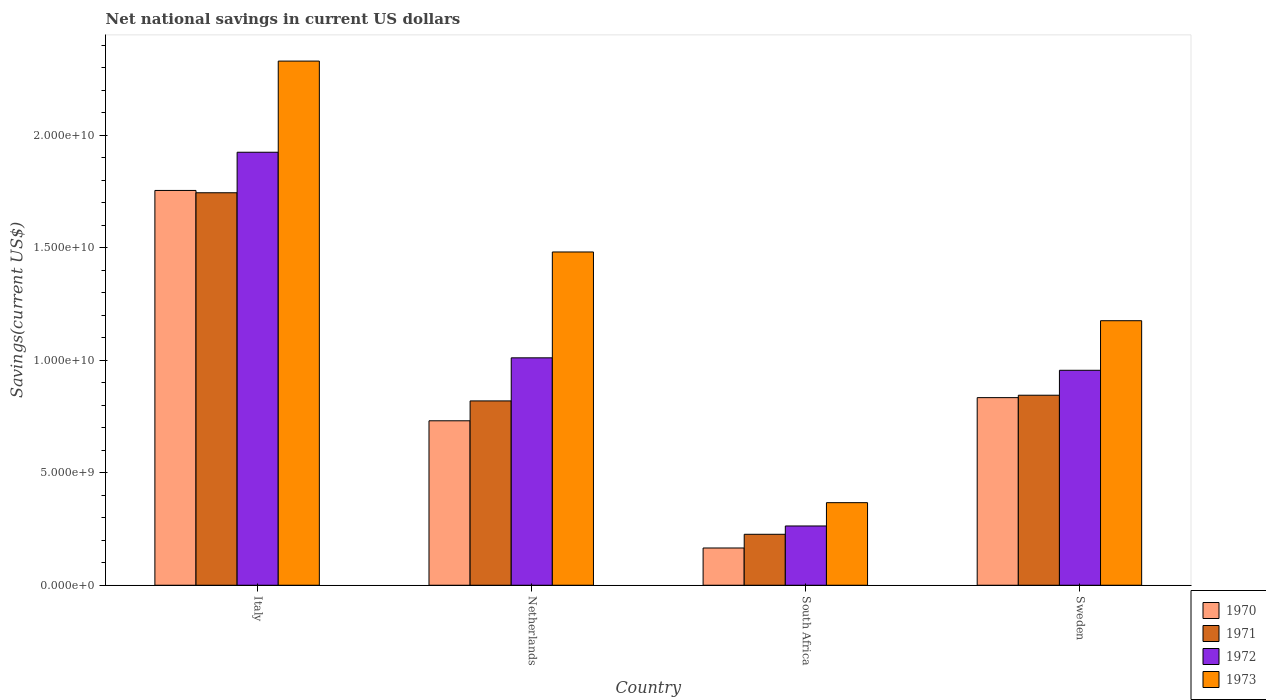How many different coloured bars are there?
Provide a succinct answer. 4. How many groups of bars are there?
Give a very brief answer. 4. How many bars are there on the 2nd tick from the left?
Keep it short and to the point. 4. What is the net national savings in 1972 in Italy?
Offer a terse response. 1.93e+1. Across all countries, what is the maximum net national savings in 1972?
Your answer should be compact. 1.93e+1. Across all countries, what is the minimum net national savings in 1971?
Give a very brief answer. 2.27e+09. In which country was the net national savings in 1972 minimum?
Your answer should be compact. South Africa. What is the total net national savings in 1970 in the graph?
Ensure brevity in your answer.  3.49e+1. What is the difference between the net national savings in 1973 in South Africa and that in Sweden?
Give a very brief answer. -8.09e+09. What is the difference between the net national savings in 1971 in Sweden and the net national savings in 1973 in South Africa?
Offer a very short reply. 4.78e+09. What is the average net national savings in 1971 per country?
Your response must be concise. 9.09e+09. What is the difference between the net national savings of/in 1971 and net national savings of/in 1973 in Italy?
Ensure brevity in your answer.  -5.86e+09. In how many countries, is the net national savings in 1972 greater than 2000000000 US$?
Your answer should be very brief. 4. What is the ratio of the net national savings in 1972 in South Africa to that in Sweden?
Your answer should be compact. 0.28. What is the difference between the highest and the second highest net national savings in 1972?
Provide a short and direct response. -9.14e+09. What is the difference between the highest and the lowest net national savings in 1972?
Your response must be concise. 1.66e+1. Is the sum of the net national savings in 1973 in Netherlands and Sweden greater than the maximum net national savings in 1972 across all countries?
Your response must be concise. Yes. Is it the case that in every country, the sum of the net national savings in 1973 and net national savings in 1970 is greater than the sum of net national savings in 1972 and net national savings in 1971?
Make the answer very short. No. What does the 1st bar from the left in Italy represents?
Make the answer very short. 1970. What does the 4th bar from the right in South Africa represents?
Provide a short and direct response. 1970. How many bars are there?
Keep it short and to the point. 16. Are all the bars in the graph horizontal?
Give a very brief answer. No. How many countries are there in the graph?
Your answer should be very brief. 4. Does the graph contain grids?
Provide a succinct answer. No. How are the legend labels stacked?
Provide a short and direct response. Vertical. What is the title of the graph?
Keep it short and to the point. Net national savings in current US dollars. What is the label or title of the Y-axis?
Offer a very short reply. Savings(current US$). What is the Savings(current US$) of 1970 in Italy?
Your response must be concise. 1.76e+1. What is the Savings(current US$) in 1971 in Italy?
Your answer should be compact. 1.75e+1. What is the Savings(current US$) of 1972 in Italy?
Your answer should be compact. 1.93e+1. What is the Savings(current US$) of 1973 in Italy?
Provide a short and direct response. 2.33e+1. What is the Savings(current US$) of 1970 in Netherlands?
Your answer should be very brief. 7.31e+09. What is the Savings(current US$) in 1971 in Netherlands?
Make the answer very short. 8.20e+09. What is the Savings(current US$) of 1972 in Netherlands?
Offer a terse response. 1.01e+1. What is the Savings(current US$) of 1973 in Netherlands?
Provide a short and direct response. 1.48e+1. What is the Savings(current US$) in 1970 in South Africa?
Provide a short and direct response. 1.66e+09. What is the Savings(current US$) in 1971 in South Africa?
Your answer should be compact. 2.27e+09. What is the Savings(current US$) in 1972 in South Africa?
Ensure brevity in your answer.  2.64e+09. What is the Savings(current US$) of 1973 in South Africa?
Your answer should be very brief. 3.67e+09. What is the Savings(current US$) in 1970 in Sweden?
Offer a terse response. 8.34e+09. What is the Savings(current US$) in 1971 in Sweden?
Your answer should be compact. 8.45e+09. What is the Savings(current US$) of 1972 in Sweden?
Offer a very short reply. 9.56e+09. What is the Savings(current US$) of 1973 in Sweden?
Provide a succinct answer. 1.18e+1. Across all countries, what is the maximum Savings(current US$) in 1970?
Provide a succinct answer. 1.76e+1. Across all countries, what is the maximum Savings(current US$) of 1971?
Offer a terse response. 1.75e+1. Across all countries, what is the maximum Savings(current US$) of 1972?
Offer a terse response. 1.93e+1. Across all countries, what is the maximum Savings(current US$) in 1973?
Keep it short and to the point. 2.33e+1. Across all countries, what is the minimum Savings(current US$) in 1970?
Give a very brief answer. 1.66e+09. Across all countries, what is the minimum Savings(current US$) in 1971?
Give a very brief answer. 2.27e+09. Across all countries, what is the minimum Savings(current US$) of 1972?
Your answer should be very brief. 2.64e+09. Across all countries, what is the minimum Savings(current US$) in 1973?
Make the answer very short. 3.67e+09. What is the total Savings(current US$) in 1970 in the graph?
Your answer should be very brief. 3.49e+1. What is the total Savings(current US$) of 1971 in the graph?
Provide a short and direct response. 3.64e+1. What is the total Savings(current US$) of 1972 in the graph?
Provide a succinct answer. 4.16e+1. What is the total Savings(current US$) of 1973 in the graph?
Your response must be concise. 5.36e+1. What is the difference between the Savings(current US$) of 1970 in Italy and that in Netherlands?
Ensure brevity in your answer.  1.02e+1. What is the difference between the Savings(current US$) of 1971 in Italy and that in Netherlands?
Provide a succinct answer. 9.26e+09. What is the difference between the Savings(current US$) of 1972 in Italy and that in Netherlands?
Ensure brevity in your answer.  9.14e+09. What is the difference between the Savings(current US$) of 1973 in Italy and that in Netherlands?
Your response must be concise. 8.49e+09. What is the difference between the Savings(current US$) of 1970 in Italy and that in South Africa?
Your response must be concise. 1.59e+1. What is the difference between the Savings(current US$) in 1971 in Italy and that in South Africa?
Make the answer very short. 1.52e+1. What is the difference between the Savings(current US$) in 1972 in Italy and that in South Africa?
Provide a succinct answer. 1.66e+1. What is the difference between the Savings(current US$) of 1973 in Italy and that in South Africa?
Provide a succinct answer. 1.96e+1. What is the difference between the Savings(current US$) in 1970 in Italy and that in Sweden?
Make the answer very short. 9.21e+09. What is the difference between the Savings(current US$) in 1971 in Italy and that in Sweden?
Ensure brevity in your answer.  9.00e+09. What is the difference between the Savings(current US$) in 1972 in Italy and that in Sweden?
Offer a very short reply. 9.70e+09. What is the difference between the Savings(current US$) of 1973 in Italy and that in Sweden?
Make the answer very short. 1.15e+1. What is the difference between the Savings(current US$) of 1970 in Netherlands and that in South Africa?
Your answer should be very brief. 5.66e+09. What is the difference between the Savings(current US$) in 1971 in Netherlands and that in South Africa?
Make the answer very short. 5.93e+09. What is the difference between the Savings(current US$) of 1972 in Netherlands and that in South Africa?
Keep it short and to the point. 7.48e+09. What is the difference between the Savings(current US$) of 1973 in Netherlands and that in South Africa?
Ensure brevity in your answer.  1.11e+1. What is the difference between the Savings(current US$) of 1970 in Netherlands and that in Sweden?
Provide a short and direct response. -1.03e+09. What is the difference between the Savings(current US$) in 1971 in Netherlands and that in Sweden?
Give a very brief answer. -2.53e+08. What is the difference between the Savings(current US$) in 1972 in Netherlands and that in Sweden?
Provide a succinct answer. 5.54e+08. What is the difference between the Savings(current US$) in 1973 in Netherlands and that in Sweden?
Ensure brevity in your answer.  3.06e+09. What is the difference between the Savings(current US$) in 1970 in South Africa and that in Sweden?
Your answer should be very brief. -6.69e+09. What is the difference between the Savings(current US$) of 1971 in South Africa and that in Sweden?
Provide a succinct answer. -6.18e+09. What is the difference between the Savings(current US$) of 1972 in South Africa and that in Sweden?
Provide a short and direct response. -6.92e+09. What is the difference between the Savings(current US$) of 1973 in South Africa and that in Sweden?
Provide a succinct answer. -8.09e+09. What is the difference between the Savings(current US$) of 1970 in Italy and the Savings(current US$) of 1971 in Netherlands?
Provide a succinct answer. 9.36e+09. What is the difference between the Savings(current US$) in 1970 in Italy and the Savings(current US$) in 1972 in Netherlands?
Your response must be concise. 7.44e+09. What is the difference between the Savings(current US$) of 1970 in Italy and the Savings(current US$) of 1973 in Netherlands?
Give a very brief answer. 2.74e+09. What is the difference between the Savings(current US$) of 1971 in Italy and the Savings(current US$) of 1972 in Netherlands?
Ensure brevity in your answer.  7.34e+09. What is the difference between the Savings(current US$) of 1971 in Italy and the Savings(current US$) of 1973 in Netherlands?
Your answer should be very brief. 2.63e+09. What is the difference between the Savings(current US$) in 1972 in Italy and the Savings(current US$) in 1973 in Netherlands?
Ensure brevity in your answer.  4.44e+09. What is the difference between the Savings(current US$) in 1970 in Italy and the Savings(current US$) in 1971 in South Africa?
Ensure brevity in your answer.  1.53e+1. What is the difference between the Savings(current US$) of 1970 in Italy and the Savings(current US$) of 1972 in South Africa?
Provide a succinct answer. 1.49e+1. What is the difference between the Savings(current US$) of 1970 in Italy and the Savings(current US$) of 1973 in South Africa?
Your response must be concise. 1.39e+1. What is the difference between the Savings(current US$) of 1971 in Italy and the Savings(current US$) of 1972 in South Africa?
Make the answer very short. 1.48e+1. What is the difference between the Savings(current US$) of 1971 in Italy and the Savings(current US$) of 1973 in South Africa?
Provide a succinct answer. 1.38e+1. What is the difference between the Savings(current US$) in 1972 in Italy and the Savings(current US$) in 1973 in South Africa?
Keep it short and to the point. 1.56e+1. What is the difference between the Savings(current US$) in 1970 in Italy and the Savings(current US$) in 1971 in Sweden?
Keep it short and to the point. 9.11e+09. What is the difference between the Savings(current US$) of 1970 in Italy and the Savings(current US$) of 1972 in Sweden?
Provide a short and direct response. 8.00e+09. What is the difference between the Savings(current US$) in 1970 in Italy and the Savings(current US$) in 1973 in Sweden?
Your answer should be compact. 5.79e+09. What is the difference between the Savings(current US$) in 1971 in Italy and the Savings(current US$) in 1972 in Sweden?
Your answer should be very brief. 7.89e+09. What is the difference between the Savings(current US$) of 1971 in Italy and the Savings(current US$) of 1973 in Sweden?
Your answer should be very brief. 5.69e+09. What is the difference between the Savings(current US$) of 1972 in Italy and the Savings(current US$) of 1973 in Sweden?
Make the answer very short. 7.49e+09. What is the difference between the Savings(current US$) of 1970 in Netherlands and the Savings(current US$) of 1971 in South Africa?
Keep it short and to the point. 5.05e+09. What is the difference between the Savings(current US$) in 1970 in Netherlands and the Savings(current US$) in 1972 in South Africa?
Provide a succinct answer. 4.68e+09. What is the difference between the Savings(current US$) of 1970 in Netherlands and the Savings(current US$) of 1973 in South Africa?
Make the answer very short. 3.64e+09. What is the difference between the Savings(current US$) in 1971 in Netherlands and the Savings(current US$) in 1972 in South Africa?
Give a very brief answer. 5.56e+09. What is the difference between the Savings(current US$) in 1971 in Netherlands and the Savings(current US$) in 1973 in South Africa?
Give a very brief answer. 4.52e+09. What is the difference between the Savings(current US$) of 1972 in Netherlands and the Savings(current US$) of 1973 in South Africa?
Your response must be concise. 6.44e+09. What is the difference between the Savings(current US$) in 1970 in Netherlands and the Savings(current US$) in 1971 in Sweden?
Offer a terse response. -1.14e+09. What is the difference between the Savings(current US$) in 1970 in Netherlands and the Savings(current US$) in 1972 in Sweden?
Your answer should be compact. -2.25e+09. What is the difference between the Savings(current US$) in 1970 in Netherlands and the Savings(current US$) in 1973 in Sweden?
Offer a terse response. -4.45e+09. What is the difference between the Savings(current US$) in 1971 in Netherlands and the Savings(current US$) in 1972 in Sweden?
Give a very brief answer. -1.36e+09. What is the difference between the Savings(current US$) of 1971 in Netherlands and the Savings(current US$) of 1973 in Sweden?
Your answer should be very brief. -3.57e+09. What is the difference between the Savings(current US$) of 1972 in Netherlands and the Savings(current US$) of 1973 in Sweden?
Provide a succinct answer. -1.65e+09. What is the difference between the Savings(current US$) of 1970 in South Africa and the Savings(current US$) of 1971 in Sweden?
Make the answer very short. -6.79e+09. What is the difference between the Savings(current US$) in 1970 in South Africa and the Savings(current US$) in 1972 in Sweden?
Keep it short and to the point. -7.90e+09. What is the difference between the Savings(current US$) in 1970 in South Africa and the Savings(current US$) in 1973 in Sweden?
Offer a terse response. -1.01e+1. What is the difference between the Savings(current US$) of 1971 in South Africa and the Savings(current US$) of 1972 in Sweden?
Your response must be concise. -7.29e+09. What is the difference between the Savings(current US$) in 1971 in South Africa and the Savings(current US$) in 1973 in Sweden?
Your response must be concise. -9.50e+09. What is the difference between the Savings(current US$) of 1972 in South Africa and the Savings(current US$) of 1973 in Sweden?
Your response must be concise. -9.13e+09. What is the average Savings(current US$) of 1970 per country?
Offer a terse response. 8.72e+09. What is the average Savings(current US$) of 1971 per country?
Your response must be concise. 9.09e+09. What is the average Savings(current US$) of 1972 per country?
Give a very brief answer. 1.04e+1. What is the average Savings(current US$) in 1973 per country?
Offer a very short reply. 1.34e+1. What is the difference between the Savings(current US$) in 1970 and Savings(current US$) in 1971 in Italy?
Your response must be concise. 1.03e+08. What is the difference between the Savings(current US$) in 1970 and Savings(current US$) in 1972 in Italy?
Provide a short and direct response. -1.70e+09. What is the difference between the Savings(current US$) in 1970 and Savings(current US$) in 1973 in Italy?
Keep it short and to the point. -5.75e+09. What is the difference between the Savings(current US$) in 1971 and Savings(current US$) in 1972 in Italy?
Offer a very short reply. -1.80e+09. What is the difference between the Savings(current US$) of 1971 and Savings(current US$) of 1973 in Italy?
Provide a short and direct response. -5.86e+09. What is the difference between the Savings(current US$) of 1972 and Savings(current US$) of 1973 in Italy?
Offer a terse response. -4.05e+09. What is the difference between the Savings(current US$) in 1970 and Savings(current US$) in 1971 in Netherlands?
Make the answer very short. -8.83e+08. What is the difference between the Savings(current US$) of 1970 and Savings(current US$) of 1972 in Netherlands?
Ensure brevity in your answer.  -2.80e+09. What is the difference between the Savings(current US$) of 1970 and Savings(current US$) of 1973 in Netherlands?
Offer a very short reply. -7.51e+09. What is the difference between the Savings(current US$) of 1971 and Savings(current US$) of 1972 in Netherlands?
Your answer should be very brief. -1.92e+09. What is the difference between the Savings(current US$) in 1971 and Savings(current US$) in 1973 in Netherlands?
Provide a short and direct response. -6.62e+09. What is the difference between the Savings(current US$) in 1972 and Savings(current US$) in 1973 in Netherlands?
Keep it short and to the point. -4.71e+09. What is the difference between the Savings(current US$) of 1970 and Savings(current US$) of 1971 in South Africa?
Give a very brief answer. -6.09e+08. What is the difference between the Savings(current US$) in 1970 and Savings(current US$) in 1972 in South Africa?
Provide a succinct answer. -9.79e+08. What is the difference between the Savings(current US$) in 1970 and Savings(current US$) in 1973 in South Africa?
Your response must be concise. -2.02e+09. What is the difference between the Savings(current US$) of 1971 and Savings(current US$) of 1972 in South Africa?
Offer a terse response. -3.70e+08. What is the difference between the Savings(current US$) of 1971 and Savings(current US$) of 1973 in South Africa?
Keep it short and to the point. -1.41e+09. What is the difference between the Savings(current US$) of 1972 and Savings(current US$) of 1973 in South Africa?
Give a very brief answer. -1.04e+09. What is the difference between the Savings(current US$) in 1970 and Savings(current US$) in 1971 in Sweden?
Your response must be concise. -1.07e+08. What is the difference between the Savings(current US$) of 1970 and Savings(current US$) of 1972 in Sweden?
Keep it short and to the point. -1.22e+09. What is the difference between the Savings(current US$) of 1970 and Savings(current US$) of 1973 in Sweden?
Offer a terse response. -3.42e+09. What is the difference between the Savings(current US$) of 1971 and Savings(current US$) of 1972 in Sweden?
Your answer should be very brief. -1.11e+09. What is the difference between the Savings(current US$) in 1971 and Savings(current US$) in 1973 in Sweden?
Give a very brief answer. -3.31e+09. What is the difference between the Savings(current US$) of 1972 and Savings(current US$) of 1973 in Sweden?
Provide a succinct answer. -2.20e+09. What is the ratio of the Savings(current US$) of 1970 in Italy to that in Netherlands?
Ensure brevity in your answer.  2.4. What is the ratio of the Savings(current US$) of 1971 in Italy to that in Netherlands?
Offer a terse response. 2.13. What is the ratio of the Savings(current US$) of 1972 in Italy to that in Netherlands?
Your response must be concise. 1.9. What is the ratio of the Savings(current US$) in 1973 in Italy to that in Netherlands?
Give a very brief answer. 1.57. What is the ratio of the Savings(current US$) of 1970 in Italy to that in South Africa?
Keep it short and to the point. 10.6. What is the ratio of the Savings(current US$) of 1971 in Italy to that in South Africa?
Provide a succinct answer. 7.7. What is the ratio of the Savings(current US$) of 1972 in Italy to that in South Africa?
Keep it short and to the point. 7.31. What is the ratio of the Savings(current US$) of 1973 in Italy to that in South Africa?
Provide a short and direct response. 6.35. What is the ratio of the Savings(current US$) in 1970 in Italy to that in Sweden?
Make the answer very short. 2.1. What is the ratio of the Savings(current US$) in 1971 in Italy to that in Sweden?
Offer a terse response. 2.07. What is the ratio of the Savings(current US$) in 1972 in Italy to that in Sweden?
Provide a short and direct response. 2.01. What is the ratio of the Savings(current US$) in 1973 in Italy to that in Sweden?
Give a very brief answer. 1.98. What is the ratio of the Savings(current US$) of 1970 in Netherlands to that in South Africa?
Provide a short and direct response. 4.42. What is the ratio of the Savings(current US$) of 1971 in Netherlands to that in South Africa?
Ensure brevity in your answer.  3.62. What is the ratio of the Savings(current US$) of 1972 in Netherlands to that in South Africa?
Ensure brevity in your answer.  3.84. What is the ratio of the Savings(current US$) of 1973 in Netherlands to that in South Africa?
Ensure brevity in your answer.  4.04. What is the ratio of the Savings(current US$) of 1970 in Netherlands to that in Sweden?
Provide a short and direct response. 0.88. What is the ratio of the Savings(current US$) in 1972 in Netherlands to that in Sweden?
Your answer should be very brief. 1.06. What is the ratio of the Savings(current US$) in 1973 in Netherlands to that in Sweden?
Give a very brief answer. 1.26. What is the ratio of the Savings(current US$) in 1970 in South Africa to that in Sweden?
Offer a terse response. 0.2. What is the ratio of the Savings(current US$) of 1971 in South Africa to that in Sweden?
Keep it short and to the point. 0.27. What is the ratio of the Savings(current US$) in 1972 in South Africa to that in Sweden?
Keep it short and to the point. 0.28. What is the ratio of the Savings(current US$) in 1973 in South Africa to that in Sweden?
Give a very brief answer. 0.31. What is the difference between the highest and the second highest Savings(current US$) of 1970?
Your answer should be compact. 9.21e+09. What is the difference between the highest and the second highest Savings(current US$) of 1971?
Provide a succinct answer. 9.00e+09. What is the difference between the highest and the second highest Savings(current US$) of 1972?
Your answer should be compact. 9.14e+09. What is the difference between the highest and the second highest Savings(current US$) in 1973?
Keep it short and to the point. 8.49e+09. What is the difference between the highest and the lowest Savings(current US$) of 1970?
Your answer should be very brief. 1.59e+1. What is the difference between the highest and the lowest Savings(current US$) of 1971?
Make the answer very short. 1.52e+1. What is the difference between the highest and the lowest Savings(current US$) in 1972?
Offer a very short reply. 1.66e+1. What is the difference between the highest and the lowest Savings(current US$) in 1973?
Offer a terse response. 1.96e+1. 